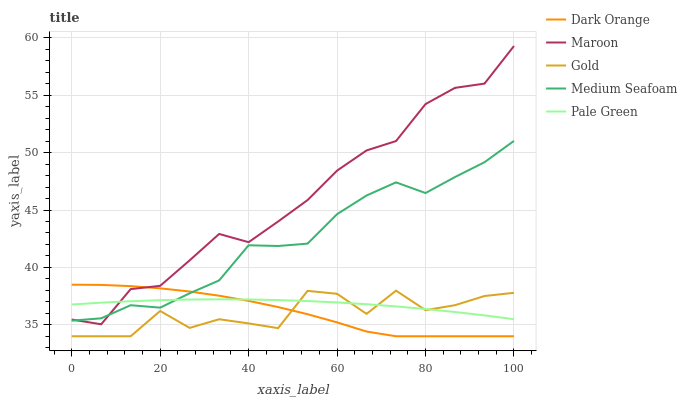Does Gold have the minimum area under the curve?
Answer yes or no. Yes. Does Maroon have the maximum area under the curve?
Answer yes or no. Yes. Does Pale Green have the minimum area under the curve?
Answer yes or no. No. Does Pale Green have the maximum area under the curve?
Answer yes or no. No. Is Pale Green the smoothest?
Answer yes or no. Yes. Is Gold the roughest?
Answer yes or no. Yes. Is Gold the smoothest?
Answer yes or no. No. Is Pale Green the roughest?
Answer yes or no. No. Does Dark Orange have the lowest value?
Answer yes or no. Yes. Does Pale Green have the lowest value?
Answer yes or no. No. Does Maroon have the highest value?
Answer yes or no. Yes. Does Gold have the highest value?
Answer yes or no. No. Is Gold less than Medium Seafoam?
Answer yes or no. Yes. Is Medium Seafoam greater than Gold?
Answer yes or no. Yes. Does Maroon intersect Dark Orange?
Answer yes or no. Yes. Is Maroon less than Dark Orange?
Answer yes or no. No. Is Maroon greater than Dark Orange?
Answer yes or no. No. Does Gold intersect Medium Seafoam?
Answer yes or no. No. 